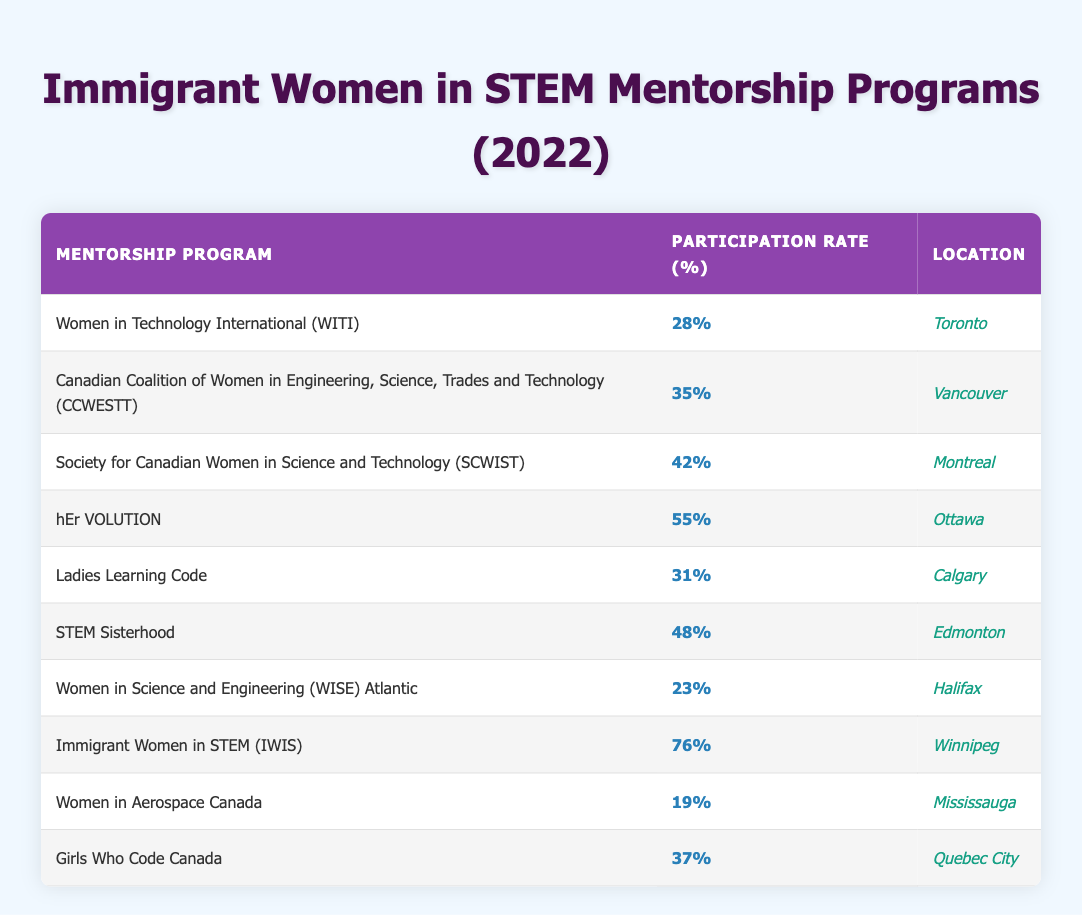What is the highest participation rate for immigrant women in a mentorship program? By examining the "Immigrant Women Participation Rate (%)" column, the highest value is 76%, which corresponds to the "Immigrant Women in STEM (IWIS)" program in Winnipeg.
Answer: 76% Which mentorship program in Edmonton has a participation rate of 48%? The program listed under Edmonton with a participation rate of 48% is "STEM Sisterhood."
Answer: STEM Sisterhood What is the average participation rate of the mentorship programs located in Canadian cities with names starting with 'W'? The relevant programs are "Women in Technology International (WITI)" with 28% and "Women in Science and Engineering (WISE) Atlantic" with 23%. The average is calculated as (28 + 23) / 2 = 25.5%.
Answer: 25.5% Is the participation rate for "Women in Aerospace Canada" higher than 20%? The participation rate for "Women in Aerospace Canada" is listed as 19%, which is less than 20%. Therefore, the statement is false.
Answer: No Which program has the second highest participation rate, and what is that rate? Sorting the participation rates from highest to lowest shows that "hEr VOLUTION" has the second highest rate at 55%, following "Immigrant Women in STEM (IWIS)" at 76%.
Answer: hEr VOLUTION, 55% 